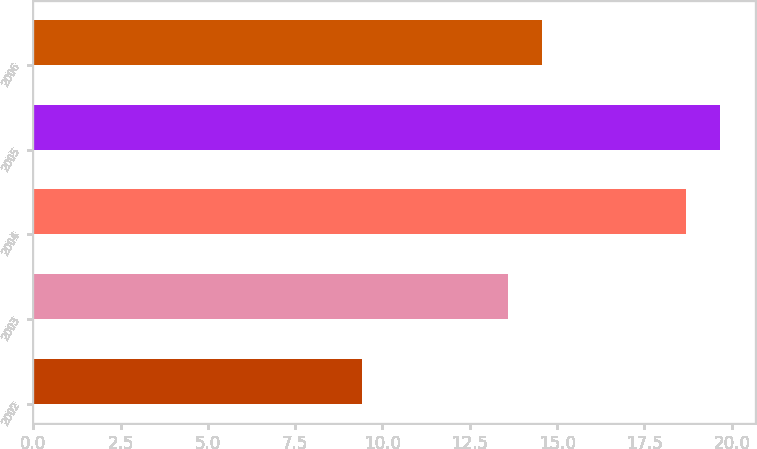Convert chart. <chart><loc_0><loc_0><loc_500><loc_500><bar_chart><fcel>2002<fcel>2003<fcel>2004<fcel>2005<fcel>2006<nl><fcel>9.4<fcel>13.6<fcel>18.7<fcel>19.67<fcel>14.57<nl></chart> 